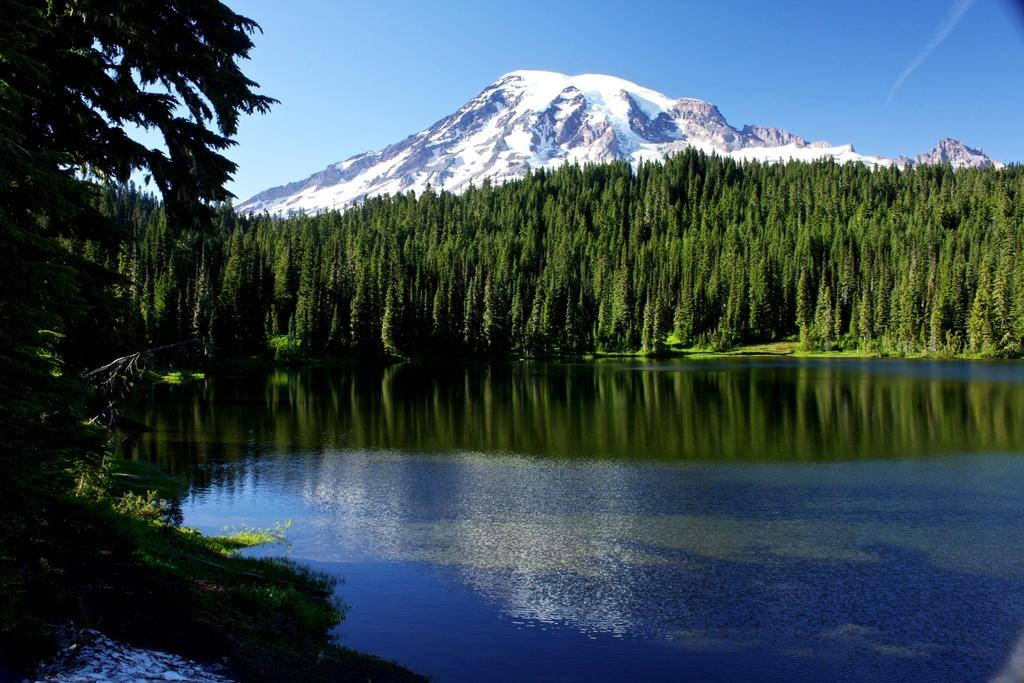What type of natural feature is present in the image? There is a lake in the image. What other natural elements can be seen in the image? There are trees in the image. What is visible in the background of the image? There is a hill in the background of the image, and the sky is also visible. What is the condition of the hill in the image? The hill has snow on it. What type of vest is the stranger wearing in the image? There is no stranger present in the image, so it is not possible to determine what type of vest they might be wearing. 